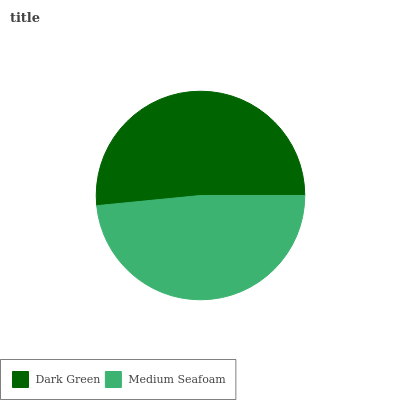Is Medium Seafoam the minimum?
Answer yes or no. Yes. Is Dark Green the maximum?
Answer yes or no. Yes. Is Medium Seafoam the maximum?
Answer yes or no. No. Is Dark Green greater than Medium Seafoam?
Answer yes or no. Yes. Is Medium Seafoam less than Dark Green?
Answer yes or no. Yes. Is Medium Seafoam greater than Dark Green?
Answer yes or no. No. Is Dark Green less than Medium Seafoam?
Answer yes or no. No. Is Dark Green the high median?
Answer yes or no. Yes. Is Medium Seafoam the low median?
Answer yes or no. Yes. Is Medium Seafoam the high median?
Answer yes or no. No. Is Dark Green the low median?
Answer yes or no. No. 